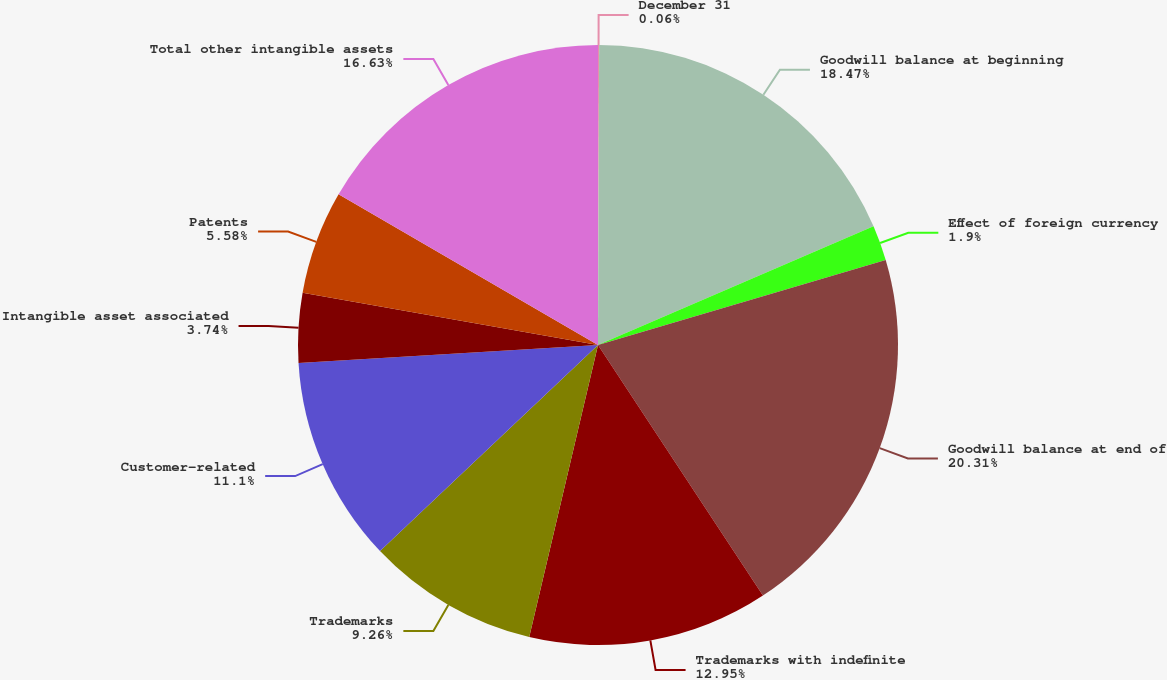<chart> <loc_0><loc_0><loc_500><loc_500><pie_chart><fcel>December 31<fcel>Goodwill balance at beginning<fcel>Effect of foreign currency<fcel>Goodwill balance at end of<fcel>Trademarks with indefinite<fcel>Trademarks<fcel>Customer-related<fcel>Intangible asset associated<fcel>Patents<fcel>Total other intangible assets<nl><fcel>0.06%<fcel>18.46%<fcel>1.9%<fcel>20.3%<fcel>12.94%<fcel>9.26%<fcel>11.1%<fcel>3.74%<fcel>5.58%<fcel>16.62%<nl></chart> 